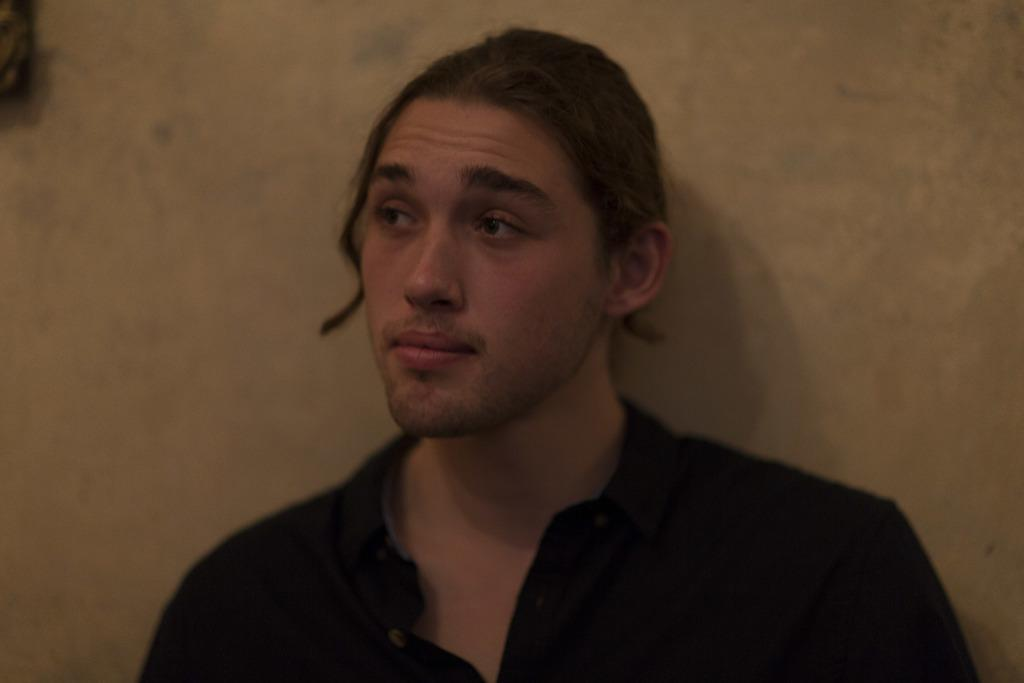What is present in the image? There is a man in the image. What is the man wearing? The man is wearing a black shirt. How many ducks are swimming in the water behind the man in the image? There is no water or ducks visible in the image; it only features a man wearing a black shirt. What type of act is the man performing in the image? There is no act or performance depicted in the image; it simply shows a man wearing a black shirt. 